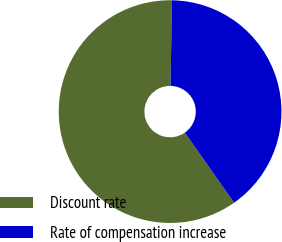Convert chart. <chart><loc_0><loc_0><loc_500><loc_500><pie_chart><fcel>Discount rate<fcel>Rate of compensation increase<nl><fcel>60.0%<fcel>40.0%<nl></chart> 